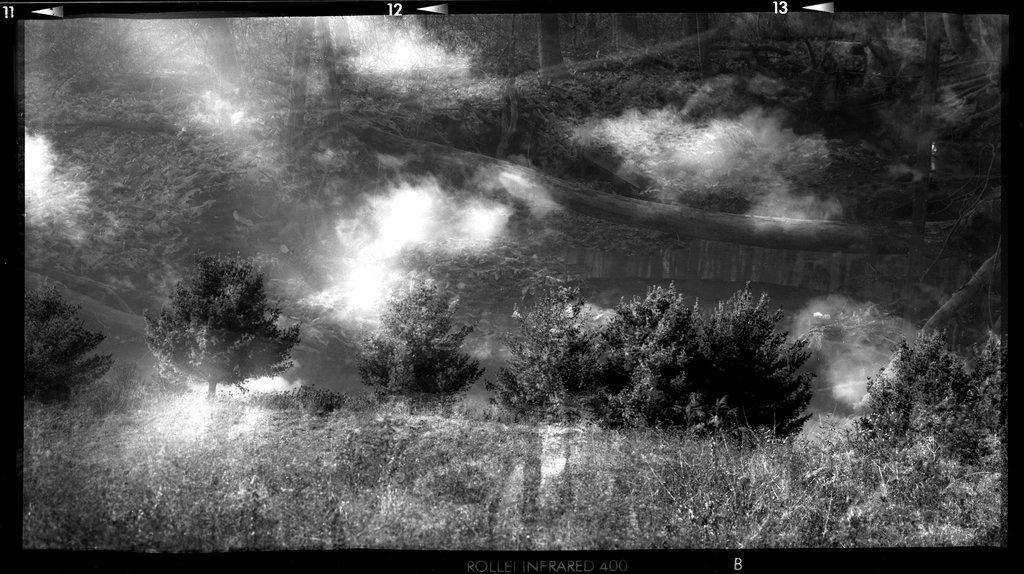Could you give a brief overview of what you see in this image? In the image there are trees in the background on a grass land and above its sky with clouds, this is a black and white picture. 